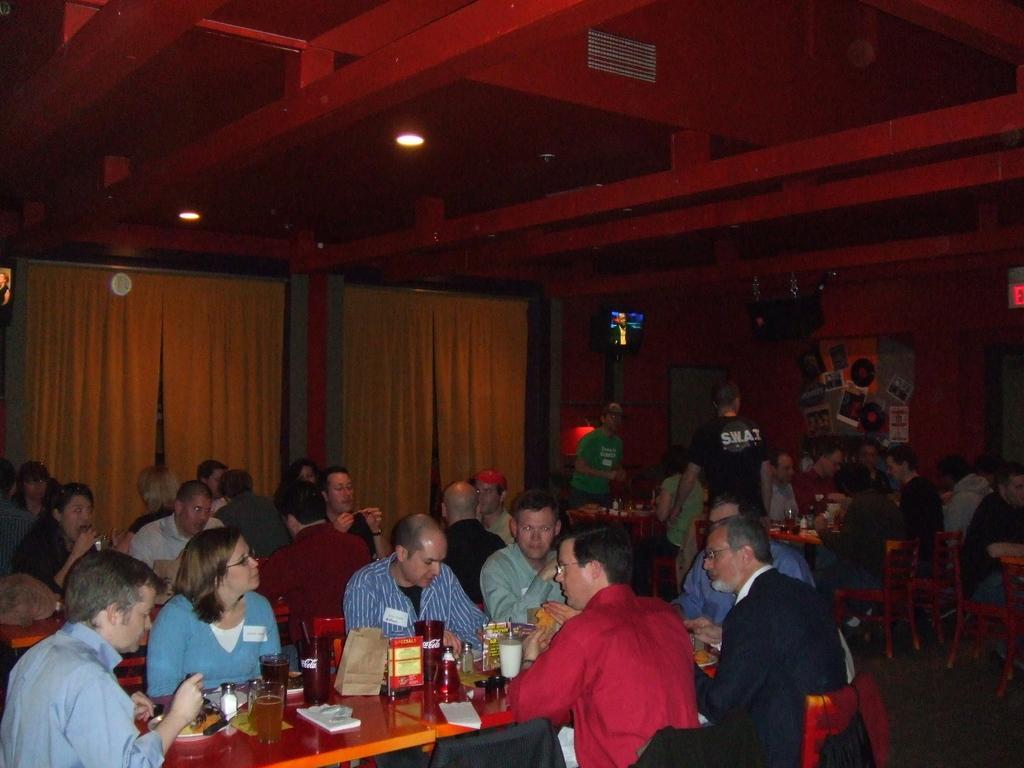In one or two sentences, can you explain what this image depicts? People are sitting on chairs. In-front of them there are tables, on these tables there are glasses and things. These are curtains. Lights are attached to the ceiling. Posters are on the wall. Far there is a television and signboard. On these chairs there are jackets. These two people are standing. 